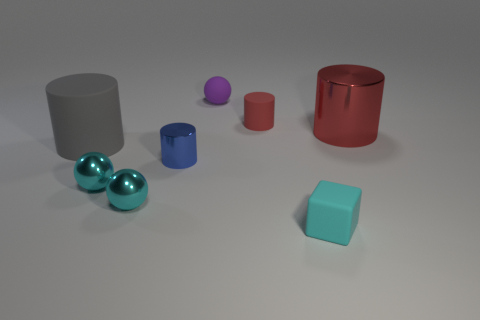How many other objects are the same size as the blue object?
Your answer should be compact. 5. Is the color of the tiny matte cylinder the same as the shiny cylinder that is to the left of the rubber block?
Your answer should be compact. No. What number of cubes are red shiny things or tiny red things?
Your answer should be compact. 0. Is there any other thing that is the same color as the small block?
Provide a short and direct response. Yes. The small cylinder behind the metallic cylinder that is behind the large gray rubber thing is made of what material?
Your response must be concise. Rubber. Are the cube and the big cylinder that is to the left of the cyan matte thing made of the same material?
Give a very brief answer. Yes. How many things are large cylinders that are right of the rubber ball or blue metallic cylinders?
Your answer should be very brief. 2. Are there any other blocks that have the same color as the cube?
Offer a very short reply. No. Do the gray rubber object and the metallic object on the right side of the purple rubber thing have the same shape?
Provide a short and direct response. Yes. How many cylinders are both in front of the red rubber cylinder and right of the tiny blue shiny cylinder?
Provide a short and direct response. 1. 